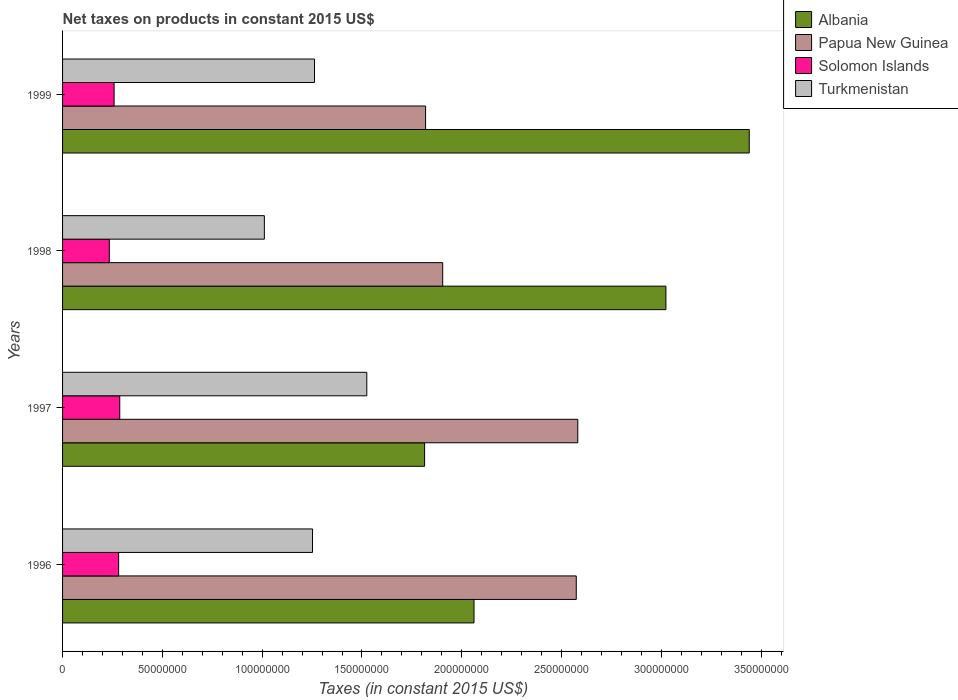How many groups of bars are there?
Offer a terse response. 4. Are the number of bars per tick equal to the number of legend labels?
Offer a very short reply. Yes. Are the number of bars on each tick of the Y-axis equal?
Keep it short and to the point. Yes. How many bars are there on the 1st tick from the top?
Ensure brevity in your answer.  4. How many bars are there on the 1st tick from the bottom?
Your answer should be very brief. 4. In how many cases, is the number of bars for a given year not equal to the number of legend labels?
Make the answer very short. 0. What is the net taxes on products in Turkmenistan in 1996?
Offer a very short reply. 1.25e+08. Across all years, what is the maximum net taxes on products in Albania?
Your response must be concise. 3.44e+08. Across all years, what is the minimum net taxes on products in Papua New Guinea?
Offer a terse response. 1.82e+08. What is the total net taxes on products in Papua New Guinea in the graph?
Your answer should be very brief. 8.88e+08. What is the difference between the net taxes on products in Albania in 1997 and that in 1998?
Provide a short and direct response. -1.21e+08. What is the difference between the net taxes on products in Solomon Islands in 1996 and the net taxes on products in Papua New Guinea in 1998?
Make the answer very short. -1.62e+08. What is the average net taxes on products in Albania per year?
Your answer should be compact. 2.58e+08. In the year 1999, what is the difference between the net taxes on products in Turkmenistan and net taxes on products in Solomon Islands?
Offer a very short reply. 1.00e+08. What is the ratio of the net taxes on products in Turkmenistan in 1996 to that in 1999?
Provide a short and direct response. 0.99. What is the difference between the highest and the second highest net taxes on products in Solomon Islands?
Provide a succinct answer. 5.57e+05. What is the difference between the highest and the lowest net taxes on products in Albania?
Offer a terse response. 1.63e+08. In how many years, is the net taxes on products in Solomon Islands greater than the average net taxes on products in Solomon Islands taken over all years?
Keep it short and to the point. 2. Is the sum of the net taxes on products in Solomon Islands in 1998 and 1999 greater than the maximum net taxes on products in Papua New Guinea across all years?
Offer a terse response. No. What does the 3rd bar from the top in 1996 represents?
Make the answer very short. Papua New Guinea. What does the 1st bar from the bottom in 1998 represents?
Your answer should be very brief. Albania. Is it the case that in every year, the sum of the net taxes on products in Solomon Islands and net taxes on products in Turkmenistan is greater than the net taxes on products in Albania?
Ensure brevity in your answer.  No. How many bars are there?
Your response must be concise. 16. Are the values on the major ticks of X-axis written in scientific E-notation?
Offer a very short reply. No. How many legend labels are there?
Ensure brevity in your answer.  4. How are the legend labels stacked?
Make the answer very short. Vertical. What is the title of the graph?
Your answer should be compact. Net taxes on products in constant 2015 US$. What is the label or title of the X-axis?
Give a very brief answer. Taxes (in constant 2015 US$). What is the Taxes (in constant 2015 US$) in Albania in 1996?
Your answer should be compact. 2.06e+08. What is the Taxes (in constant 2015 US$) of Papua New Guinea in 1996?
Offer a terse response. 2.57e+08. What is the Taxes (in constant 2015 US$) of Solomon Islands in 1996?
Your response must be concise. 2.81e+07. What is the Taxes (in constant 2015 US$) of Turkmenistan in 1996?
Give a very brief answer. 1.25e+08. What is the Taxes (in constant 2015 US$) in Albania in 1997?
Give a very brief answer. 1.81e+08. What is the Taxes (in constant 2015 US$) of Papua New Guinea in 1997?
Make the answer very short. 2.58e+08. What is the Taxes (in constant 2015 US$) in Solomon Islands in 1997?
Your answer should be very brief. 2.87e+07. What is the Taxes (in constant 2015 US$) in Turkmenistan in 1997?
Keep it short and to the point. 1.52e+08. What is the Taxes (in constant 2015 US$) of Albania in 1998?
Provide a short and direct response. 3.02e+08. What is the Taxes (in constant 2015 US$) in Papua New Guinea in 1998?
Provide a succinct answer. 1.90e+08. What is the Taxes (in constant 2015 US$) in Solomon Islands in 1998?
Provide a succinct answer. 2.34e+07. What is the Taxes (in constant 2015 US$) in Turkmenistan in 1998?
Your answer should be very brief. 1.01e+08. What is the Taxes (in constant 2015 US$) in Albania in 1999?
Give a very brief answer. 3.44e+08. What is the Taxes (in constant 2015 US$) of Papua New Guinea in 1999?
Provide a short and direct response. 1.82e+08. What is the Taxes (in constant 2015 US$) of Solomon Islands in 1999?
Your response must be concise. 2.58e+07. What is the Taxes (in constant 2015 US$) in Turkmenistan in 1999?
Provide a short and direct response. 1.26e+08. Across all years, what is the maximum Taxes (in constant 2015 US$) of Albania?
Offer a very short reply. 3.44e+08. Across all years, what is the maximum Taxes (in constant 2015 US$) of Papua New Guinea?
Offer a very short reply. 2.58e+08. Across all years, what is the maximum Taxes (in constant 2015 US$) of Solomon Islands?
Your answer should be compact. 2.87e+07. Across all years, what is the maximum Taxes (in constant 2015 US$) in Turkmenistan?
Provide a short and direct response. 1.52e+08. Across all years, what is the minimum Taxes (in constant 2015 US$) in Albania?
Provide a short and direct response. 1.81e+08. Across all years, what is the minimum Taxes (in constant 2015 US$) in Papua New Guinea?
Make the answer very short. 1.82e+08. Across all years, what is the minimum Taxes (in constant 2015 US$) in Solomon Islands?
Your answer should be compact. 2.34e+07. Across all years, what is the minimum Taxes (in constant 2015 US$) in Turkmenistan?
Ensure brevity in your answer.  1.01e+08. What is the total Taxes (in constant 2015 US$) in Albania in the graph?
Make the answer very short. 1.03e+09. What is the total Taxes (in constant 2015 US$) in Papua New Guinea in the graph?
Offer a very short reply. 8.88e+08. What is the total Taxes (in constant 2015 US$) in Solomon Islands in the graph?
Make the answer very short. 1.06e+08. What is the total Taxes (in constant 2015 US$) of Turkmenistan in the graph?
Your answer should be very brief. 5.05e+08. What is the difference between the Taxes (in constant 2015 US$) of Albania in 1996 and that in 1997?
Give a very brief answer. 2.48e+07. What is the difference between the Taxes (in constant 2015 US$) in Papua New Guinea in 1996 and that in 1997?
Offer a terse response. -7.72e+05. What is the difference between the Taxes (in constant 2015 US$) in Solomon Islands in 1996 and that in 1997?
Offer a terse response. -5.57e+05. What is the difference between the Taxes (in constant 2015 US$) of Turkmenistan in 1996 and that in 1997?
Offer a very short reply. -2.72e+07. What is the difference between the Taxes (in constant 2015 US$) of Albania in 1996 and that in 1998?
Ensure brevity in your answer.  -9.61e+07. What is the difference between the Taxes (in constant 2015 US$) in Papua New Guinea in 1996 and that in 1998?
Provide a short and direct response. 6.69e+07. What is the difference between the Taxes (in constant 2015 US$) in Solomon Islands in 1996 and that in 1998?
Give a very brief answer. 4.67e+06. What is the difference between the Taxes (in constant 2015 US$) of Turkmenistan in 1996 and that in 1998?
Your answer should be very brief. 2.41e+07. What is the difference between the Taxes (in constant 2015 US$) of Albania in 1996 and that in 1999?
Make the answer very short. -1.38e+08. What is the difference between the Taxes (in constant 2015 US$) of Papua New Guinea in 1996 and that in 1999?
Offer a terse response. 7.55e+07. What is the difference between the Taxes (in constant 2015 US$) of Solomon Islands in 1996 and that in 1999?
Offer a terse response. 2.28e+06. What is the difference between the Taxes (in constant 2015 US$) of Turkmenistan in 1996 and that in 1999?
Provide a short and direct response. -9.94e+05. What is the difference between the Taxes (in constant 2015 US$) of Albania in 1997 and that in 1998?
Ensure brevity in your answer.  -1.21e+08. What is the difference between the Taxes (in constant 2015 US$) in Papua New Guinea in 1997 and that in 1998?
Make the answer very short. 6.77e+07. What is the difference between the Taxes (in constant 2015 US$) of Solomon Islands in 1997 and that in 1998?
Offer a terse response. 5.23e+06. What is the difference between the Taxes (in constant 2015 US$) in Turkmenistan in 1997 and that in 1998?
Your response must be concise. 5.13e+07. What is the difference between the Taxes (in constant 2015 US$) of Albania in 1997 and that in 1999?
Make the answer very short. -1.63e+08. What is the difference between the Taxes (in constant 2015 US$) in Papua New Guinea in 1997 and that in 1999?
Provide a short and direct response. 7.63e+07. What is the difference between the Taxes (in constant 2015 US$) in Solomon Islands in 1997 and that in 1999?
Your answer should be compact. 2.84e+06. What is the difference between the Taxes (in constant 2015 US$) of Turkmenistan in 1997 and that in 1999?
Give a very brief answer. 2.62e+07. What is the difference between the Taxes (in constant 2015 US$) in Albania in 1998 and that in 1999?
Offer a terse response. -4.17e+07. What is the difference between the Taxes (in constant 2015 US$) of Papua New Guinea in 1998 and that in 1999?
Ensure brevity in your answer.  8.57e+06. What is the difference between the Taxes (in constant 2015 US$) in Solomon Islands in 1998 and that in 1999?
Keep it short and to the point. -2.39e+06. What is the difference between the Taxes (in constant 2015 US$) in Turkmenistan in 1998 and that in 1999?
Offer a very short reply. -2.51e+07. What is the difference between the Taxes (in constant 2015 US$) in Albania in 1996 and the Taxes (in constant 2015 US$) in Papua New Guinea in 1997?
Make the answer very short. -5.20e+07. What is the difference between the Taxes (in constant 2015 US$) of Albania in 1996 and the Taxes (in constant 2015 US$) of Solomon Islands in 1997?
Your response must be concise. 1.77e+08. What is the difference between the Taxes (in constant 2015 US$) in Albania in 1996 and the Taxes (in constant 2015 US$) in Turkmenistan in 1997?
Provide a succinct answer. 5.37e+07. What is the difference between the Taxes (in constant 2015 US$) in Papua New Guinea in 1996 and the Taxes (in constant 2015 US$) in Solomon Islands in 1997?
Ensure brevity in your answer.  2.29e+08. What is the difference between the Taxes (in constant 2015 US$) of Papua New Guinea in 1996 and the Taxes (in constant 2015 US$) of Turkmenistan in 1997?
Your answer should be compact. 1.05e+08. What is the difference between the Taxes (in constant 2015 US$) of Solomon Islands in 1996 and the Taxes (in constant 2015 US$) of Turkmenistan in 1997?
Provide a short and direct response. -1.24e+08. What is the difference between the Taxes (in constant 2015 US$) of Albania in 1996 and the Taxes (in constant 2015 US$) of Papua New Guinea in 1998?
Provide a succinct answer. 1.57e+07. What is the difference between the Taxes (in constant 2015 US$) in Albania in 1996 and the Taxes (in constant 2015 US$) in Solomon Islands in 1998?
Ensure brevity in your answer.  1.83e+08. What is the difference between the Taxes (in constant 2015 US$) of Albania in 1996 and the Taxes (in constant 2015 US$) of Turkmenistan in 1998?
Provide a short and direct response. 1.05e+08. What is the difference between the Taxes (in constant 2015 US$) of Papua New Guinea in 1996 and the Taxes (in constant 2015 US$) of Solomon Islands in 1998?
Your answer should be very brief. 2.34e+08. What is the difference between the Taxes (in constant 2015 US$) of Papua New Guinea in 1996 and the Taxes (in constant 2015 US$) of Turkmenistan in 1998?
Offer a very short reply. 1.56e+08. What is the difference between the Taxes (in constant 2015 US$) of Solomon Islands in 1996 and the Taxes (in constant 2015 US$) of Turkmenistan in 1998?
Offer a very short reply. -7.30e+07. What is the difference between the Taxes (in constant 2015 US$) in Albania in 1996 and the Taxes (in constant 2015 US$) in Papua New Guinea in 1999?
Your answer should be very brief. 2.43e+07. What is the difference between the Taxes (in constant 2015 US$) of Albania in 1996 and the Taxes (in constant 2015 US$) of Solomon Islands in 1999?
Make the answer very short. 1.80e+08. What is the difference between the Taxes (in constant 2015 US$) in Albania in 1996 and the Taxes (in constant 2015 US$) in Turkmenistan in 1999?
Give a very brief answer. 7.99e+07. What is the difference between the Taxes (in constant 2015 US$) of Papua New Guinea in 1996 and the Taxes (in constant 2015 US$) of Solomon Islands in 1999?
Your answer should be very brief. 2.32e+08. What is the difference between the Taxes (in constant 2015 US$) in Papua New Guinea in 1996 and the Taxes (in constant 2015 US$) in Turkmenistan in 1999?
Give a very brief answer. 1.31e+08. What is the difference between the Taxes (in constant 2015 US$) of Solomon Islands in 1996 and the Taxes (in constant 2015 US$) of Turkmenistan in 1999?
Your answer should be very brief. -9.81e+07. What is the difference between the Taxes (in constant 2015 US$) in Albania in 1997 and the Taxes (in constant 2015 US$) in Papua New Guinea in 1998?
Offer a terse response. -9.06e+06. What is the difference between the Taxes (in constant 2015 US$) of Albania in 1997 and the Taxes (in constant 2015 US$) of Solomon Islands in 1998?
Make the answer very short. 1.58e+08. What is the difference between the Taxes (in constant 2015 US$) of Albania in 1997 and the Taxes (in constant 2015 US$) of Turkmenistan in 1998?
Your answer should be very brief. 8.03e+07. What is the difference between the Taxes (in constant 2015 US$) in Papua New Guinea in 1997 and the Taxes (in constant 2015 US$) in Solomon Islands in 1998?
Make the answer very short. 2.35e+08. What is the difference between the Taxes (in constant 2015 US$) of Papua New Guinea in 1997 and the Taxes (in constant 2015 US$) of Turkmenistan in 1998?
Keep it short and to the point. 1.57e+08. What is the difference between the Taxes (in constant 2015 US$) of Solomon Islands in 1997 and the Taxes (in constant 2015 US$) of Turkmenistan in 1998?
Keep it short and to the point. -7.24e+07. What is the difference between the Taxes (in constant 2015 US$) in Albania in 1997 and the Taxes (in constant 2015 US$) in Papua New Guinea in 1999?
Ensure brevity in your answer.  -4.93e+05. What is the difference between the Taxes (in constant 2015 US$) in Albania in 1997 and the Taxes (in constant 2015 US$) in Solomon Islands in 1999?
Make the answer very short. 1.56e+08. What is the difference between the Taxes (in constant 2015 US$) in Albania in 1997 and the Taxes (in constant 2015 US$) in Turkmenistan in 1999?
Give a very brief answer. 5.52e+07. What is the difference between the Taxes (in constant 2015 US$) in Papua New Guinea in 1997 and the Taxes (in constant 2015 US$) in Solomon Islands in 1999?
Give a very brief answer. 2.32e+08. What is the difference between the Taxes (in constant 2015 US$) of Papua New Guinea in 1997 and the Taxes (in constant 2015 US$) of Turkmenistan in 1999?
Your response must be concise. 1.32e+08. What is the difference between the Taxes (in constant 2015 US$) of Solomon Islands in 1997 and the Taxes (in constant 2015 US$) of Turkmenistan in 1999?
Ensure brevity in your answer.  -9.76e+07. What is the difference between the Taxes (in constant 2015 US$) in Albania in 1998 and the Taxes (in constant 2015 US$) in Papua New Guinea in 1999?
Your answer should be compact. 1.20e+08. What is the difference between the Taxes (in constant 2015 US$) in Albania in 1998 and the Taxes (in constant 2015 US$) in Solomon Islands in 1999?
Offer a terse response. 2.76e+08. What is the difference between the Taxes (in constant 2015 US$) of Albania in 1998 and the Taxes (in constant 2015 US$) of Turkmenistan in 1999?
Offer a very short reply. 1.76e+08. What is the difference between the Taxes (in constant 2015 US$) in Papua New Guinea in 1998 and the Taxes (in constant 2015 US$) in Solomon Islands in 1999?
Give a very brief answer. 1.65e+08. What is the difference between the Taxes (in constant 2015 US$) of Papua New Guinea in 1998 and the Taxes (in constant 2015 US$) of Turkmenistan in 1999?
Ensure brevity in your answer.  6.42e+07. What is the difference between the Taxes (in constant 2015 US$) in Solomon Islands in 1998 and the Taxes (in constant 2015 US$) in Turkmenistan in 1999?
Offer a terse response. -1.03e+08. What is the average Taxes (in constant 2015 US$) in Albania per year?
Provide a succinct answer. 2.58e+08. What is the average Taxes (in constant 2015 US$) of Papua New Guinea per year?
Ensure brevity in your answer.  2.22e+08. What is the average Taxes (in constant 2015 US$) in Solomon Islands per year?
Offer a terse response. 2.65e+07. What is the average Taxes (in constant 2015 US$) in Turkmenistan per year?
Give a very brief answer. 1.26e+08. In the year 1996, what is the difference between the Taxes (in constant 2015 US$) of Albania and Taxes (in constant 2015 US$) of Papua New Guinea?
Provide a succinct answer. -5.12e+07. In the year 1996, what is the difference between the Taxes (in constant 2015 US$) of Albania and Taxes (in constant 2015 US$) of Solomon Islands?
Offer a very short reply. 1.78e+08. In the year 1996, what is the difference between the Taxes (in constant 2015 US$) in Albania and Taxes (in constant 2015 US$) in Turkmenistan?
Your answer should be very brief. 8.09e+07. In the year 1996, what is the difference between the Taxes (in constant 2015 US$) of Papua New Guinea and Taxes (in constant 2015 US$) of Solomon Islands?
Ensure brevity in your answer.  2.29e+08. In the year 1996, what is the difference between the Taxes (in constant 2015 US$) in Papua New Guinea and Taxes (in constant 2015 US$) in Turkmenistan?
Offer a very short reply. 1.32e+08. In the year 1996, what is the difference between the Taxes (in constant 2015 US$) in Solomon Islands and Taxes (in constant 2015 US$) in Turkmenistan?
Your answer should be very brief. -9.71e+07. In the year 1997, what is the difference between the Taxes (in constant 2015 US$) in Albania and Taxes (in constant 2015 US$) in Papua New Guinea?
Provide a succinct answer. -7.67e+07. In the year 1997, what is the difference between the Taxes (in constant 2015 US$) in Albania and Taxes (in constant 2015 US$) in Solomon Islands?
Your response must be concise. 1.53e+08. In the year 1997, what is the difference between the Taxes (in constant 2015 US$) in Albania and Taxes (in constant 2015 US$) in Turkmenistan?
Your answer should be very brief. 2.90e+07. In the year 1997, what is the difference between the Taxes (in constant 2015 US$) of Papua New Guinea and Taxes (in constant 2015 US$) of Solomon Islands?
Provide a short and direct response. 2.29e+08. In the year 1997, what is the difference between the Taxes (in constant 2015 US$) of Papua New Guinea and Taxes (in constant 2015 US$) of Turkmenistan?
Give a very brief answer. 1.06e+08. In the year 1997, what is the difference between the Taxes (in constant 2015 US$) in Solomon Islands and Taxes (in constant 2015 US$) in Turkmenistan?
Keep it short and to the point. -1.24e+08. In the year 1998, what is the difference between the Taxes (in constant 2015 US$) of Albania and Taxes (in constant 2015 US$) of Papua New Guinea?
Offer a terse response. 1.12e+08. In the year 1998, what is the difference between the Taxes (in constant 2015 US$) in Albania and Taxes (in constant 2015 US$) in Solomon Islands?
Provide a short and direct response. 2.79e+08. In the year 1998, what is the difference between the Taxes (in constant 2015 US$) in Albania and Taxes (in constant 2015 US$) in Turkmenistan?
Offer a terse response. 2.01e+08. In the year 1998, what is the difference between the Taxes (in constant 2015 US$) in Papua New Guinea and Taxes (in constant 2015 US$) in Solomon Islands?
Offer a very short reply. 1.67e+08. In the year 1998, what is the difference between the Taxes (in constant 2015 US$) of Papua New Guinea and Taxes (in constant 2015 US$) of Turkmenistan?
Your answer should be very brief. 8.94e+07. In the year 1998, what is the difference between the Taxes (in constant 2015 US$) in Solomon Islands and Taxes (in constant 2015 US$) in Turkmenistan?
Your answer should be very brief. -7.77e+07. In the year 1999, what is the difference between the Taxes (in constant 2015 US$) of Albania and Taxes (in constant 2015 US$) of Papua New Guinea?
Keep it short and to the point. 1.62e+08. In the year 1999, what is the difference between the Taxes (in constant 2015 US$) of Albania and Taxes (in constant 2015 US$) of Solomon Islands?
Keep it short and to the point. 3.18e+08. In the year 1999, what is the difference between the Taxes (in constant 2015 US$) in Albania and Taxes (in constant 2015 US$) in Turkmenistan?
Ensure brevity in your answer.  2.18e+08. In the year 1999, what is the difference between the Taxes (in constant 2015 US$) of Papua New Guinea and Taxes (in constant 2015 US$) of Solomon Islands?
Keep it short and to the point. 1.56e+08. In the year 1999, what is the difference between the Taxes (in constant 2015 US$) in Papua New Guinea and Taxes (in constant 2015 US$) in Turkmenistan?
Give a very brief answer. 5.57e+07. In the year 1999, what is the difference between the Taxes (in constant 2015 US$) in Solomon Islands and Taxes (in constant 2015 US$) in Turkmenistan?
Your answer should be compact. -1.00e+08. What is the ratio of the Taxes (in constant 2015 US$) in Albania in 1996 to that in 1997?
Offer a terse response. 1.14. What is the ratio of the Taxes (in constant 2015 US$) in Papua New Guinea in 1996 to that in 1997?
Ensure brevity in your answer.  1. What is the ratio of the Taxes (in constant 2015 US$) in Solomon Islands in 1996 to that in 1997?
Your answer should be very brief. 0.98. What is the ratio of the Taxes (in constant 2015 US$) in Turkmenistan in 1996 to that in 1997?
Your response must be concise. 0.82. What is the ratio of the Taxes (in constant 2015 US$) of Albania in 1996 to that in 1998?
Ensure brevity in your answer.  0.68. What is the ratio of the Taxes (in constant 2015 US$) in Papua New Guinea in 1996 to that in 1998?
Your response must be concise. 1.35. What is the ratio of the Taxes (in constant 2015 US$) of Solomon Islands in 1996 to that in 1998?
Provide a succinct answer. 1.2. What is the ratio of the Taxes (in constant 2015 US$) of Turkmenistan in 1996 to that in 1998?
Your answer should be compact. 1.24. What is the ratio of the Taxes (in constant 2015 US$) of Albania in 1996 to that in 1999?
Give a very brief answer. 0.6. What is the ratio of the Taxes (in constant 2015 US$) in Papua New Guinea in 1996 to that in 1999?
Your answer should be very brief. 1.42. What is the ratio of the Taxes (in constant 2015 US$) of Solomon Islands in 1996 to that in 1999?
Keep it short and to the point. 1.09. What is the ratio of the Taxes (in constant 2015 US$) of Albania in 1997 to that in 1998?
Provide a succinct answer. 0.6. What is the ratio of the Taxes (in constant 2015 US$) in Papua New Guinea in 1997 to that in 1998?
Your answer should be very brief. 1.36. What is the ratio of the Taxes (in constant 2015 US$) in Solomon Islands in 1997 to that in 1998?
Offer a terse response. 1.22. What is the ratio of the Taxes (in constant 2015 US$) of Turkmenistan in 1997 to that in 1998?
Provide a succinct answer. 1.51. What is the ratio of the Taxes (in constant 2015 US$) of Albania in 1997 to that in 1999?
Offer a terse response. 0.53. What is the ratio of the Taxes (in constant 2015 US$) in Papua New Guinea in 1997 to that in 1999?
Offer a very short reply. 1.42. What is the ratio of the Taxes (in constant 2015 US$) in Solomon Islands in 1997 to that in 1999?
Ensure brevity in your answer.  1.11. What is the ratio of the Taxes (in constant 2015 US$) of Turkmenistan in 1997 to that in 1999?
Your answer should be compact. 1.21. What is the ratio of the Taxes (in constant 2015 US$) in Albania in 1998 to that in 1999?
Offer a terse response. 0.88. What is the ratio of the Taxes (in constant 2015 US$) in Papua New Guinea in 1998 to that in 1999?
Offer a terse response. 1.05. What is the ratio of the Taxes (in constant 2015 US$) in Solomon Islands in 1998 to that in 1999?
Give a very brief answer. 0.91. What is the ratio of the Taxes (in constant 2015 US$) of Turkmenistan in 1998 to that in 1999?
Your answer should be compact. 0.8. What is the difference between the highest and the second highest Taxes (in constant 2015 US$) in Albania?
Your response must be concise. 4.17e+07. What is the difference between the highest and the second highest Taxes (in constant 2015 US$) of Papua New Guinea?
Keep it short and to the point. 7.72e+05. What is the difference between the highest and the second highest Taxes (in constant 2015 US$) of Solomon Islands?
Provide a succinct answer. 5.57e+05. What is the difference between the highest and the second highest Taxes (in constant 2015 US$) of Turkmenistan?
Keep it short and to the point. 2.62e+07. What is the difference between the highest and the lowest Taxes (in constant 2015 US$) of Albania?
Keep it short and to the point. 1.63e+08. What is the difference between the highest and the lowest Taxes (in constant 2015 US$) of Papua New Guinea?
Offer a terse response. 7.63e+07. What is the difference between the highest and the lowest Taxes (in constant 2015 US$) of Solomon Islands?
Provide a short and direct response. 5.23e+06. What is the difference between the highest and the lowest Taxes (in constant 2015 US$) in Turkmenistan?
Ensure brevity in your answer.  5.13e+07. 